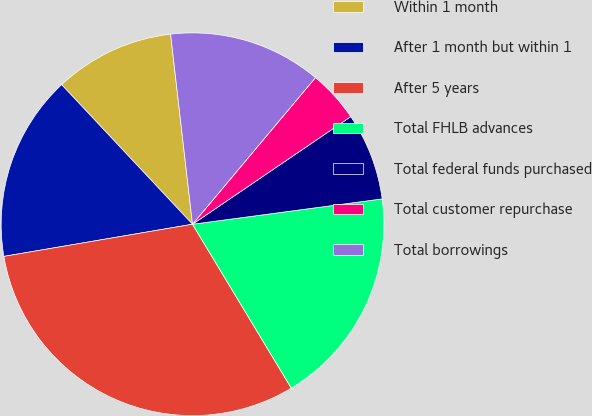Convert chart. <chart><loc_0><loc_0><loc_500><loc_500><pie_chart><fcel>Within 1 month<fcel>After 1 month but within 1<fcel>After 5 years<fcel>Total FHLB advances<fcel>Total federal funds purchased<fcel>Total customer repurchase<fcel>Total borrowings<nl><fcel>10.16%<fcel>15.7%<fcel>30.95%<fcel>18.48%<fcel>7.39%<fcel>4.39%<fcel>12.93%<nl></chart> 